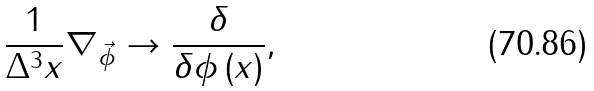Convert formula to latex. <formula><loc_0><loc_0><loc_500><loc_500>\frac { 1 } { \Delta ^ { 3 } x } \nabla _ { \vec { \phi } } \rightarrow \frac { \delta } { \delta \phi \left ( x \right ) } ,</formula> 